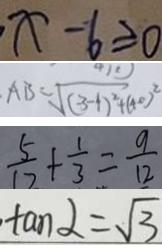Convert formula to latex. <formula><loc_0><loc_0><loc_500><loc_500>x - 6 \geq 0 
 A B = \sqrt { ( 3 - 1 ) ^ { 2 } + ( 4 0 ) ^ { 2 } } 
 \frac { 5 } { 1 2 } + \frac { 1 } { 3 } = \frac { 9 } { 1 2 } 
 \tan \alpha = \sqrt { 3 }</formula> 